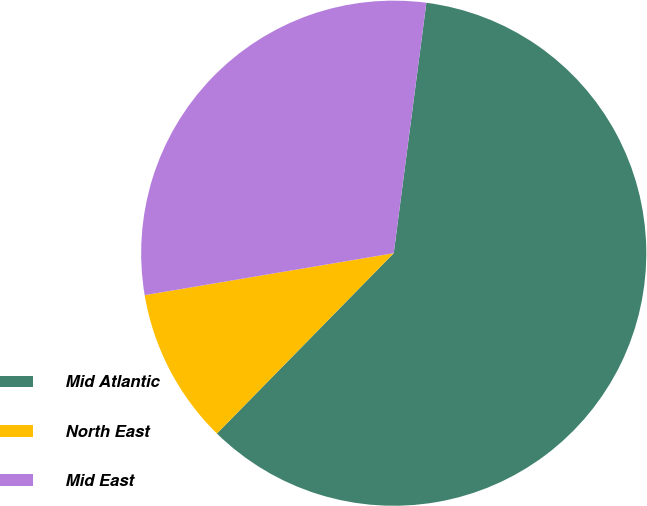<chart> <loc_0><loc_0><loc_500><loc_500><pie_chart><fcel>Mid Atlantic<fcel>North East<fcel>Mid East<nl><fcel>60.28%<fcel>10.0%<fcel>29.72%<nl></chart> 